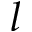Convert formula to latex. <formula><loc_0><loc_0><loc_500><loc_500>l</formula> 